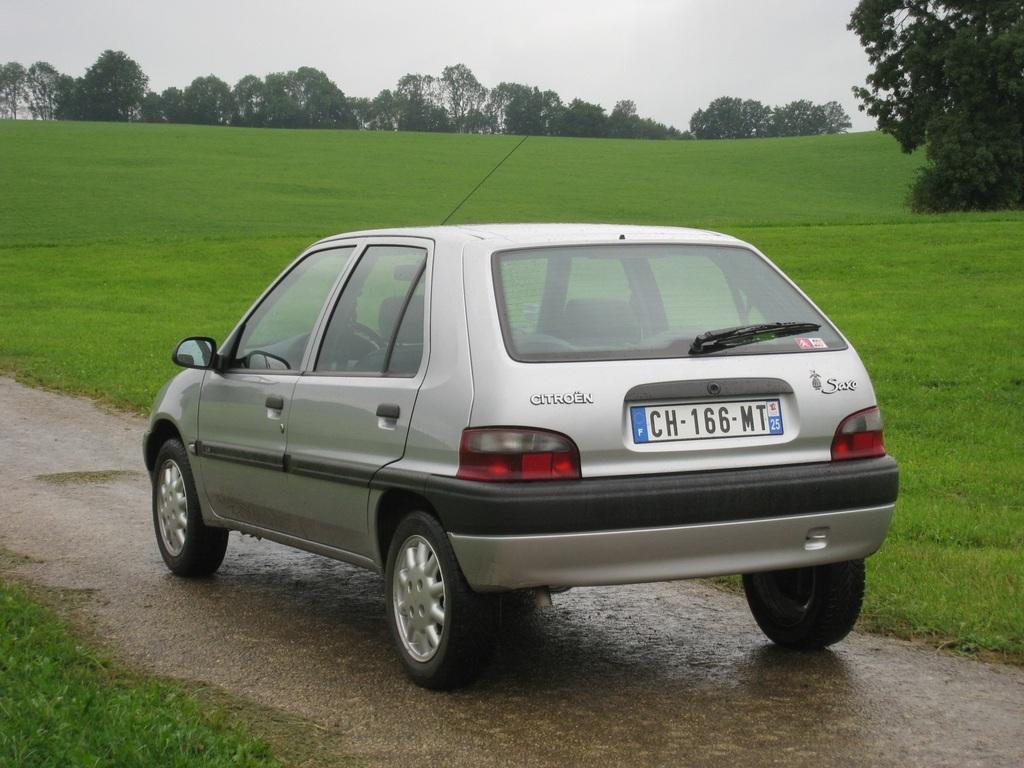Describe this image in one or two sentences. In this image I can see a car which is silver and black in color is on the road. I can see some grass on both sides of the road. In the background I can see few trees and the sky. 